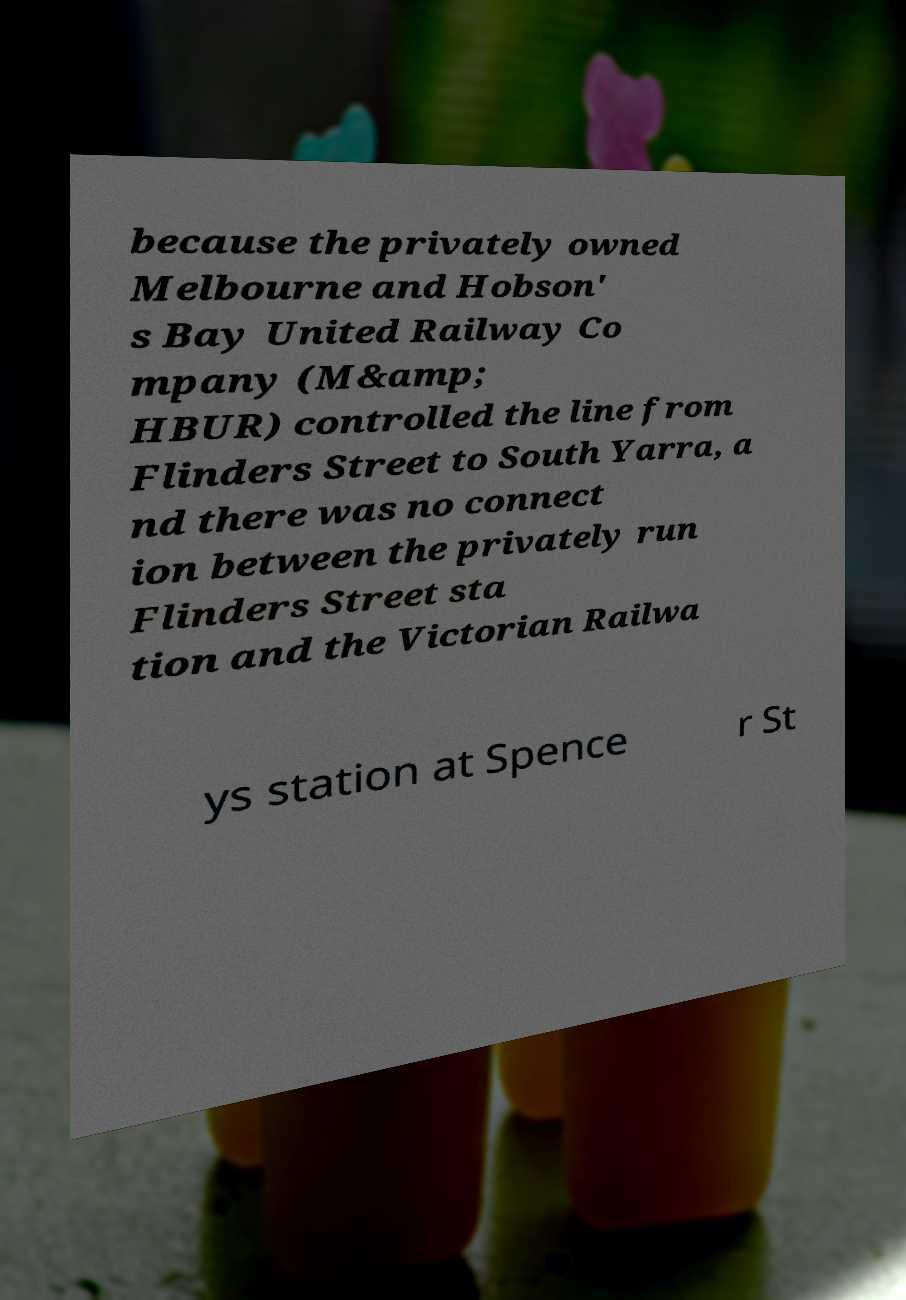There's text embedded in this image that I need extracted. Can you transcribe it verbatim? because the privately owned Melbourne and Hobson' s Bay United Railway Co mpany (M&amp; HBUR) controlled the line from Flinders Street to South Yarra, a nd there was no connect ion between the privately run Flinders Street sta tion and the Victorian Railwa ys station at Spence r St 